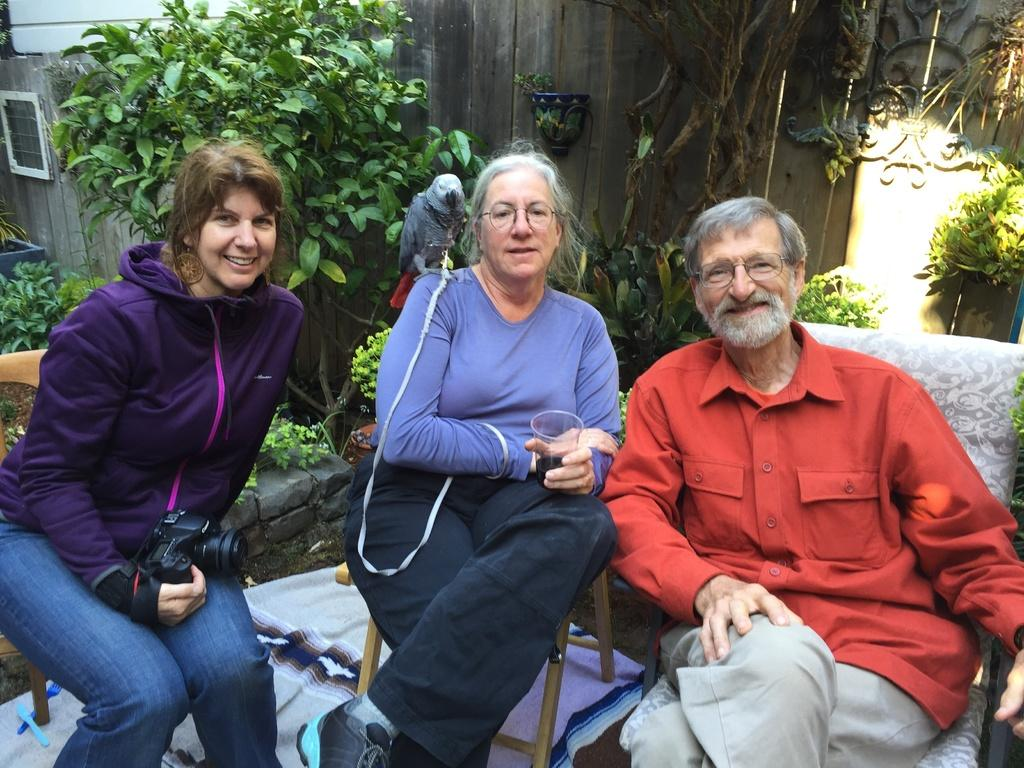How many persons are in the image? There are persons in the image. What object is present in the image that is commonly used for capturing images? There is a camera in the image. What material is present in the image that is typically transparent? There is glass in the image. What type of animal can be seen in the image? There is a bird in the image. What type of vegetation is visible in the background of the image? There are plants and trees in the background of the image. What type of structure is visible in the background of the image? There is a wall in the background of the image. What type of cub is playing in the yard in the image? There is no cub or yard present in the image. What type of ground is visible beneath the persons in the image? The ground is not visible in the image; only a wall, plants, and trees are visible in the background. 